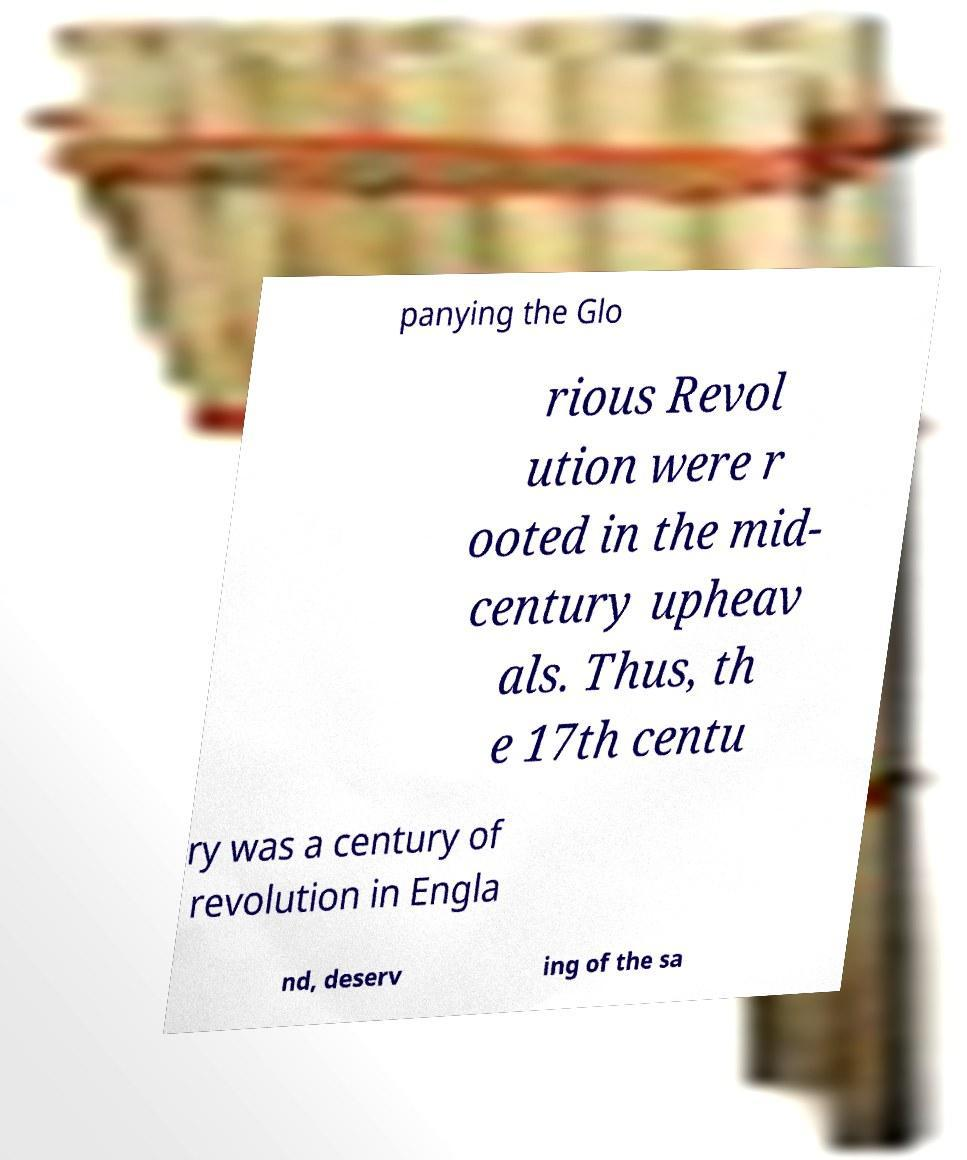I need the written content from this picture converted into text. Can you do that? panying the Glo rious Revol ution were r ooted in the mid- century upheav als. Thus, th e 17th centu ry was a century of revolution in Engla nd, deserv ing of the sa 